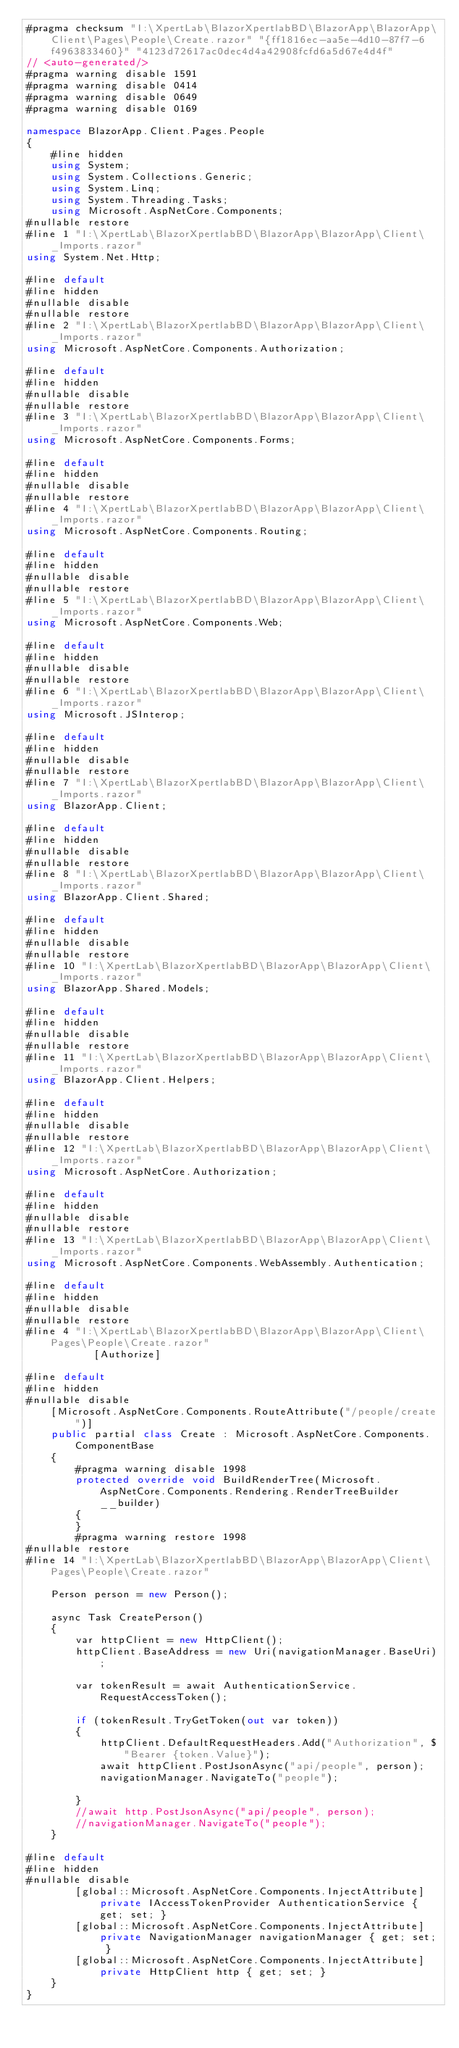Convert code to text. <code><loc_0><loc_0><loc_500><loc_500><_C#_>#pragma checksum "I:\XpertLab\BlazorXpertlabBD\BlazorApp\BlazorApp\Client\Pages\People\Create.razor" "{ff1816ec-aa5e-4d10-87f7-6f4963833460}" "4123d72617ac0dec4d4a42908fcfd6a5d67e4d4f"
// <auto-generated/>
#pragma warning disable 1591
#pragma warning disable 0414
#pragma warning disable 0649
#pragma warning disable 0169

namespace BlazorApp.Client.Pages.People
{
    #line hidden
    using System;
    using System.Collections.Generic;
    using System.Linq;
    using System.Threading.Tasks;
    using Microsoft.AspNetCore.Components;
#nullable restore
#line 1 "I:\XpertLab\BlazorXpertlabBD\BlazorApp\BlazorApp\Client\_Imports.razor"
using System.Net.Http;

#line default
#line hidden
#nullable disable
#nullable restore
#line 2 "I:\XpertLab\BlazorXpertlabBD\BlazorApp\BlazorApp\Client\_Imports.razor"
using Microsoft.AspNetCore.Components.Authorization;

#line default
#line hidden
#nullable disable
#nullable restore
#line 3 "I:\XpertLab\BlazorXpertlabBD\BlazorApp\BlazorApp\Client\_Imports.razor"
using Microsoft.AspNetCore.Components.Forms;

#line default
#line hidden
#nullable disable
#nullable restore
#line 4 "I:\XpertLab\BlazorXpertlabBD\BlazorApp\BlazorApp\Client\_Imports.razor"
using Microsoft.AspNetCore.Components.Routing;

#line default
#line hidden
#nullable disable
#nullable restore
#line 5 "I:\XpertLab\BlazorXpertlabBD\BlazorApp\BlazorApp\Client\_Imports.razor"
using Microsoft.AspNetCore.Components.Web;

#line default
#line hidden
#nullable disable
#nullable restore
#line 6 "I:\XpertLab\BlazorXpertlabBD\BlazorApp\BlazorApp\Client\_Imports.razor"
using Microsoft.JSInterop;

#line default
#line hidden
#nullable disable
#nullable restore
#line 7 "I:\XpertLab\BlazorXpertlabBD\BlazorApp\BlazorApp\Client\_Imports.razor"
using BlazorApp.Client;

#line default
#line hidden
#nullable disable
#nullable restore
#line 8 "I:\XpertLab\BlazorXpertlabBD\BlazorApp\BlazorApp\Client\_Imports.razor"
using BlazorApp.Client.Shared;

#line default
#line hidden
#nullable disable
#nullable restore
#line 10 "I:\XpertLab\BlazorXpertlabBD\BlazorApp\BlazorApp\Client\_Imports.razor"
using BlazorApp.Shared.Models;

#line default
#line hidden
#nullable disable
#nullable restore
#line 11 "I:\XpertLab\BlazorXpertlabBD\BlazorApp\BlazorApp\Client\_Imports.razor"
using BlazorApp.Client.Helpers;

#line default
#line hidden
#nullable disable
#nullable restore
#line 12 "I:\XpertLab\BlazorXpertlabBD\BlazorApp\BlazorApp\Client\_Imports.razor"
using Microsoft.AspNetCore.Authorization;

#line default
#line hidden
#nullable disable
#nullable restore
#line 13 "I:\XpertLab\BlazorXpertlabBD\BlazorApp\BlazorApp\Client\_Imports.razor"
using Microsoft.AspNetCore.Components.WebAssembly.Authentication;

#line default
#line hidden
#nullable disable
#nullable restore
#line 4 "I:\XpertLab\BlazorXpertlabBD\BlazorApp\BlazorApp\Client\Pages\People\Create.razor"
           [Authorize]

#line default
#line hidden
#nullable disable
    [Microsoft.AspNetCore.Components.RouteAttribute("/people/create")]
    public partial class Create : Microsoft.AspNetCore.Components.ComponentBase
    {
        #pragma warning disable 1998
        protected override void BuildRenderTree(Microsoft.AspNetCore.Components.Rendering.RenderTreeBuilder __builder)
        {
        }
        #pragma warning restore 1998
#nullable restore
#line 14 "I:\XpertLab\BlazorXpertlabBD\BlazorApp\BlazorApp\Client\Pages\People\Create.razor"
       
    Person person = new Person();

    async Task CreatePerson()
    {
        var httpClient = new HttpClient();
        httpClient.BaseAddress = new Uri(navigationManager.BaseUri);

        var tokenResult = await AuthenticationService.RequestAccessToken();

        if (tokenResult.TryGetToken(out var token))
        {
            httpClient.DefaultRequestHeaders.Add("Authorization", $"Bearer {token.Value}");
            await httpClient.PostJsonAsync("api/people", person);
            navigationManager.NavigateTo("people");

        }
        //await http.PostJsonAsync("api/people", person);
        //navigationManager.NavigateTo("people");
    }

#line default
#line hidden
#nullable disable
        [global::Microsoft.AspNetCore.Components.InjectAttribute] private IAccessTokenProvider AuthenticationService { get; set; }
        [global::Microsoft.AspNetCore.Components.InjectAttribute] private NavigationManager navigationManager { get; set; }
        [global::Microsoft.AspNetCore.Components.InjectAttribute] private HttpClient http { get; set; }
    }
}</code> 